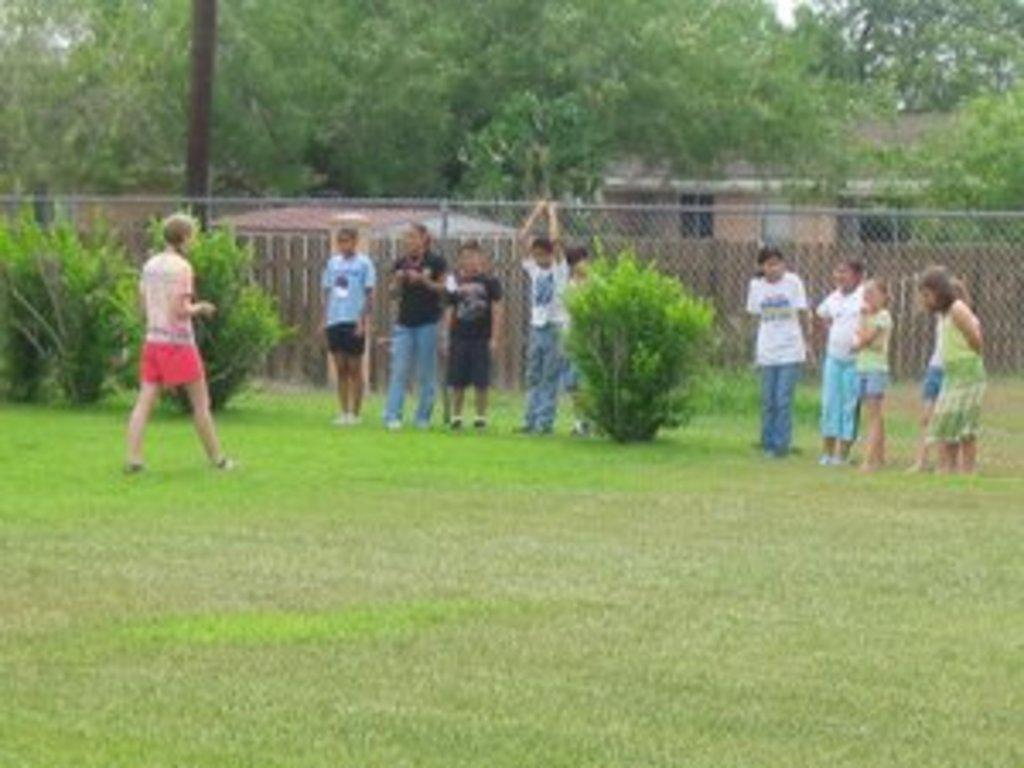What can be seen in the image? There are people standing in the image. What is at the bottom of the image? There is grass at the bottom of the image. What type of barrier is present in the image? There is fencing in the image. What can be seen in the distance in the image? There are trees in the background of the image. What is the tall, vertical object in the image? There is a pole in the image. Can you see a goat swimming in the image? There is no goat or swimming activity present in the image. 